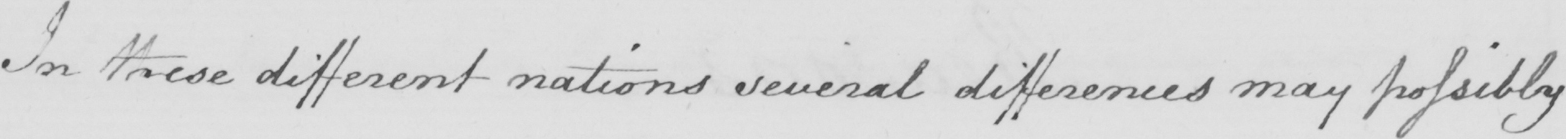Transcribe the text shown in this historical manuscript line. In these different nations several differences may possibly 